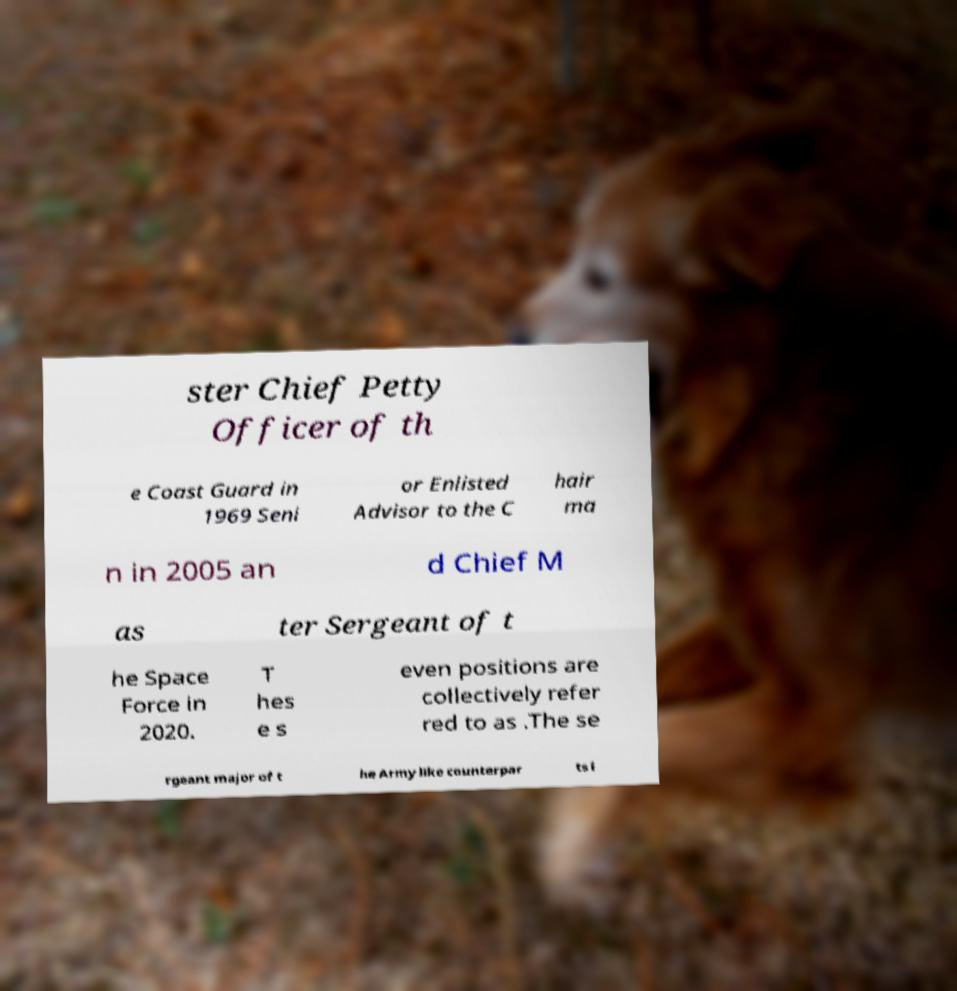Could you assist in decoding the text presented in this image and type it out clearly? ster Chief Petty Officer of th e Coast Guard in 1969 Seni or Enlisted Advisor to the C hair ma n in 2005 an d Chief M as ter Sergeant of t he Space Force in 2020. T hes e s even positions are collectively refer red to as .The se rgeant major of t he Army like counterpar ts i 